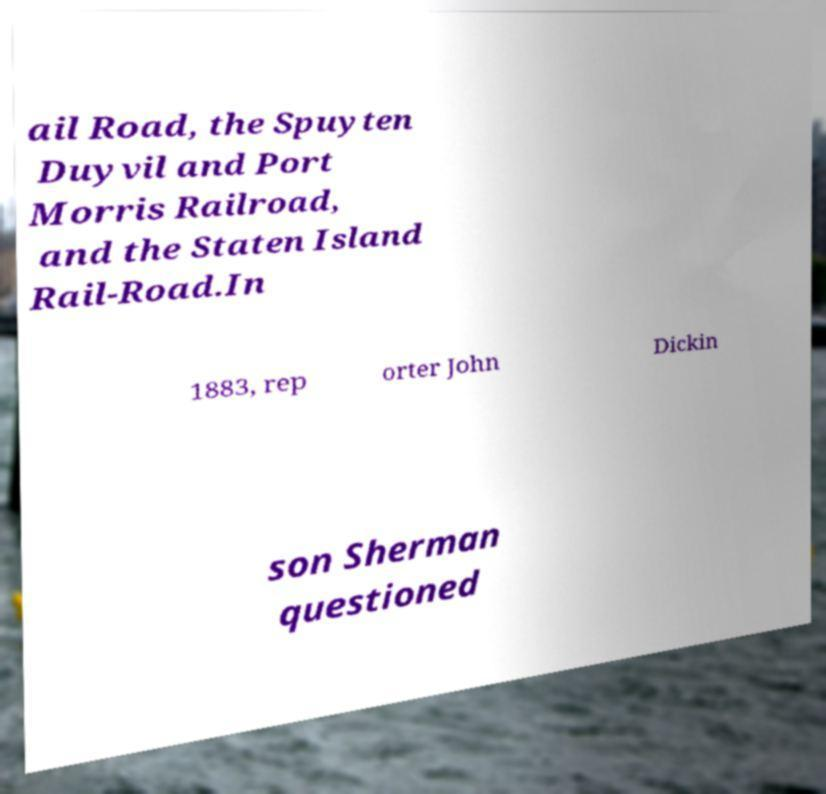Could you extract and type out the text from this image? ail Road, the Spuyten Duyvil and Port Morris Railroad, and the Staten Island Rail-Road.In 1883, rep orter John Dickin son Sherman questioned 